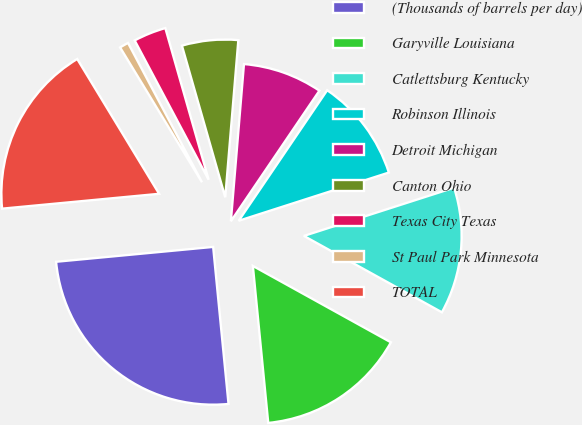Convert chart. <chart><loc_0><loc_0><loc_500><loc_500><pie_chart><fcel>(Thousands of barrels per day)<fcel>Garyville Louisiana<fcel>Catlettsburg Kentucky<fcel>Robinson Illinois<fcel>Detroit Michigan<fcel>Canton Ohio<fcel>Texas City Texas<fcel>St Paul Park Minnesota<fcel>TOTAL<nl><fcel>25.05%<fcel>15.4%<fcel>12.99%<fcel>10.57%<fcel>8.16%<fcel>5.75%<fcel>3.34%<fcel>0.92%<fcel>17.81%<nl></chart> 